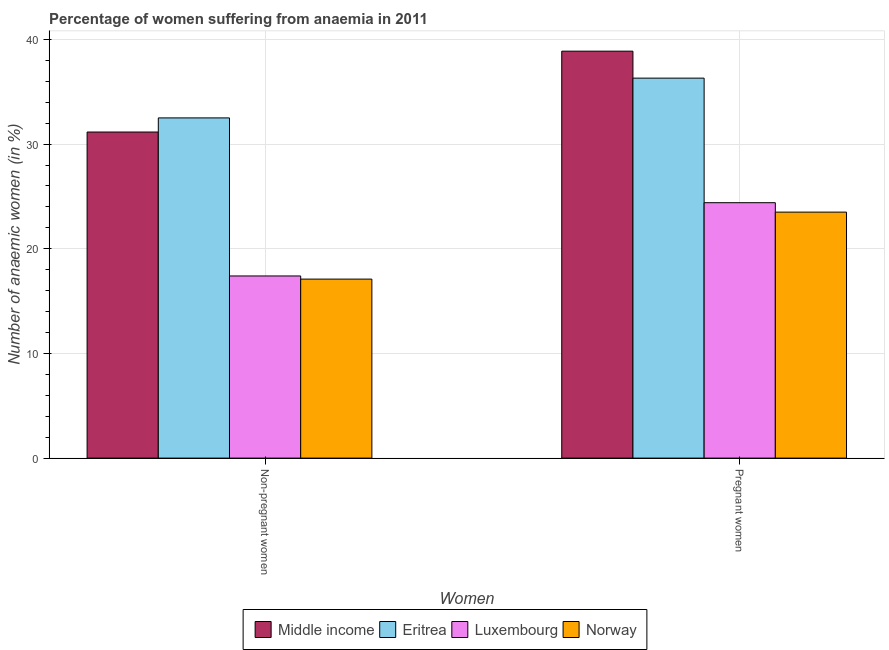How many groups of bars are there?
Make the answer very short. 2. Are the number of bars on each tick of the X-axis equal?
Ensure brevity in your answer.  Yes. How many bars are there on the 1st tick from the right?
Offer a very short reply. 4. What is the label of the 2nd group of bars from the left?
Offer a very short reply. Pregnant women. Across all countries, what is the maximum percentage of non-pregnant anaemic women?
Your answer should be very brief. 32.5. In which country was the percentage of pregnant anaemic women maximum?
Ensure brevity in your answer.  Middle income. What is the total percentage of pregnant anaemic women in the graph?
Your response must be concise. 123.08. What is the difference between the percentage of pregnant anaemic women in Luxembourg and that in Eritrea?
Ensure brevity in your answer.  -11.9. What is the difference between the percentage of non-pregnant anaemic women in Luxembourg and the percentage of pregnant anaemic women in Eritrea?
Ensure brevity in your answer.  -18.9. What is the average percentage of non-pregnant anaemic women per country?
Keep it short and to the point. 24.54. What is the difference between the percentage of non-pregnant anaemic women and percentage of pregnant anaemic women in Norway?
Give a very brief answer. -6.4. In how many countries, is the percentage of non-pregnant anaemic women greater than 4 %?
Ensure brevity in your answer.  4. What is the ratio of the percentage of non-pregnant anaemic women in Norway to that in Luxembourg?
Provide a succinct answer. 0.98. Is the percentage of pregnant anaemic women in Eritrea less than that in Luxembourg?
Give a very brief answer. No. What does the 3rd bar from the left in Non-pregnant women represents?
Offer a terse response. Luxembourg. What does the 3rd bar from the right in Pregnant women represents?
Your answer should be compact. Eritrea. Are all the bars in the graph horizontal?
Offer a very short reply. No. What is the difference between two consecutive major ticks on the Y-axis?
Ensure brevity in your answer.  10. Does the graph contain any zero values?
Ensure brevity in your answer.  No. Does the graph contain grids?
Provide a short and direct response. Yes. How many legend labels are there?
Provide a short and direct response. 4. How are the legend labels stacked?
Make the answer very short. Horizontal. What is the title of the graph?
Your answer should be compact. Percentage of women suffering from anaemia in 2011. Does "Cabo Verde" appear as one of the legend labels in the graph?
Offer a very short reply. No. What is the label or title of the X-axis?
Provide a succinct answer. Women. What is the label or title of the Y-axis?
Provide a short and direct response. Number of anaemic women (in %). What is the Number of anaemic women (in %) in Middle income in Non-pregnant women?
Give a very brief answer. 31.15. What is the Number of anaemic women (in %) in Eritrea in Non-pregnant women?
Offer a terse response. 32.5. What is the Number of anaemic women (in %) in Luxembourg in Non-pregnant women?
Ensure brevity in your answer.  17.4. What is the Number of anaemic women (in %) in Middle income in Pregnant women?
Keep it short and to the point. 38.88. What is the Number of anaemic women (in %) of Eritrea in Pregnant women?
Provide a succinct answer. 36.3. What is the Number of anaemic women (in %) in Luxembourg in Pregnant women?
Offer a terse response. 24.4. Across all Women, what is the maximum Number of anaemic women (in %) in Middle income?
Give a very brief answer. 38.88. Across all Women, what is the maximum Number of anaemic women (in %) of Eritrea?
Provide a succinct answer. 36.3. Across all Women, what is the maximum Number of anaemic women (in %) in Luxembourg?
Your response must be concise. 24.4. Across all Women, what is the minimum Number of anaemic women (in %) in Middle income?
Your response must be concise. 31.15. Across all Women, what is the minimum Number of anaemic women (in %) of Eritrea?
Your response must be concise. 32.5. Across all Women, what is the minimum Number of anaemic women (in %) of Luxembourg?
Your answer should be very brief. 17.4. What is the total Number of anaemic women (in %) in Middle income in the graph?
Your answer should be very brief. 70.03. What is the total Number of anaemic women (in %) in Eritrea in the graph?
Your answer should be compact. 68.8. What is the total Number of anaemic women (in %) of Luxembourg in the graph?
Make the answer very short. 41.8. What is the total Number of anaemic women (in %) in Norway in the graph?
Keep it short and to the point. 40.6. What is the difference between the Number of anaemic women (in %) of Middle income in Non-pregnant women and that in Pregnant women?
Make the answer very short. -7.72. What is the difference between the Number of anaemic women (in %) of Eritrea in Non-pregnant women and that in Pregnant women?
Give a very brief answer. -3.8. What is the difference between the Number of anaemic women (in %) of Norway in Non-pregnant women and that in Pregnant women?
Offer a very short reply. -6.4. What is the difference between the Number of anaemic women (in %) in Middle income in Non-pregnant women and the Number of anaemic women (in %) in Eritrea in Pregnant women?
Provide a short and direct response. -5.15. What is the difference between the Number of anaemic women (in %) of Middle income in Non-pregnant women and the Number of anaemic women (in %) of Luxembourg in Pregnant women?
Provide a short and direct response. 6.75. What is the difference between the Number of anaemic women (in %) of Middle income in Non-pregnant women and the Number of anaemic women (in %) of Norway in Pregnant women?
Your answer should be very brief. 7.65. What is the difference between the Number of anaemic women (in %) of Eritrea in Non-pregnant women and the Number of anaemic women (in %) of Luxembourg in Pregnant women?
Provide a succinct answer. 8.1. What is the difference between the Number of anaemic women (in %) of Eritrea in Non-pregnant women and the Number of anaemic women (in %) of Norway in Pregnant women?
Offer a terse response. 9. What is the difference between the Number of anaemic women (in %) of Luxembourg in Non-pregnant women and the Number of anaemic women (in %) of Norway in Pregnant women?
Offer a terse response. -6.1. What is the average Number of anaemic women (in %) in Middle income per Women?
Offer a very short reply. 35.01. What is the average Number of anaemic women (in %) of Eritrea per Women?
Your response must be concise. 34.4. What is the average Number of anaemic women (in %) in Luxembourg per Women?
Provide a succinct answer. 20.9. What is the average Number of anaemic women (in %) in Norway per Women?
Ensure brevity in your answer.  20.3. What is the difference between the Number of anaemic women (in %) in Middle income and Number of anaemic women (in %) in Eritrea in Non-pregnant women?
Your response must be concise. -1.35. What is the difference between the Number of anaemic women (in %) in Middle income and Number of anaemic women (in %) in Luxembourg in Non-pregnant women?
Provide a succinct answer. 13.75. What is the difference between the Number of anaemic women (in %) of Middle income and Number of anaemic women (in %) of Norway in Non-pregnant women?
Offer a terse response. 14.05. What is the difference between the Number of anaemic women (in %) in Eritrea and Number of anaemic women (in %) in Luxembourg in Non-pregnant women?
Offer a very short reply. 15.1. What is the difference between the Number of anaemic women (in %) of Middle income and Number of anaemic women (in %) of Eritrea in Pregnant women?
Your answer should be compact. 2.58. What is the difference between the Number of anaemic women (in %) in Middle income and Number of anaemic women (in %) in Luxembourg in Pregnant women?
Ensure brevity in your answer.  14.48. What is the difference between the Number of anaemic women (in %) in Middle income and Number of anaemic women (in %) in Norway in Pregnant women?
Provide a succinct answer. 15.38. What is the difference between the Number of anaemic women (in %) in Eritrea and Number of anaemic women (in %) in Norway in Pregnant women?
Provide a succinct answer. 12.8. What is the difference between the Number of anaemic women (in %) in Luxembourg and Number of anaemic women (in %) in Norway in Pregnant women?
Offer a very short reply. 0.9. What is the ratio of the Number of anaemic women (in %) of Middle income in Non-pregnant women to that in Pregnant women?
Ensure brevity in your answer.  0.8. What is the ratio of the Number of anaemic women (in %) of Eritrea in Non-pregnant women to that in Pregnant women?
Keep it short and to the point. 0.9. What is the ratio of the Number of anaemic women (in %) in Luxembourg in Non-pregnant women to that in Pregnant women?
Your answer should be very brief. 0.71. What is the ratio of the Number of anaemic women (in %) in Norway in Non-pregnant women to that in Pregnant women?
Your answer should be very brief. 0.73. What is the difference between the highest and the second highest Number of anaemic women (in %) of Middle income?
Your response must be concise. 7.72. What is the difference between the highest and the second highest Number of anaemic women (in %) of Eritrea?
Provide a succinct answer. 3.8. What is the difference between the highest and the lowest Number of anaemic women (in %) in Middle income?
Offer a terse response. 7.72. What is the difference between the highest and the lowest Number of anaemic women (in %) of Eritrea?
Provide a short and direct response. 3.8. 